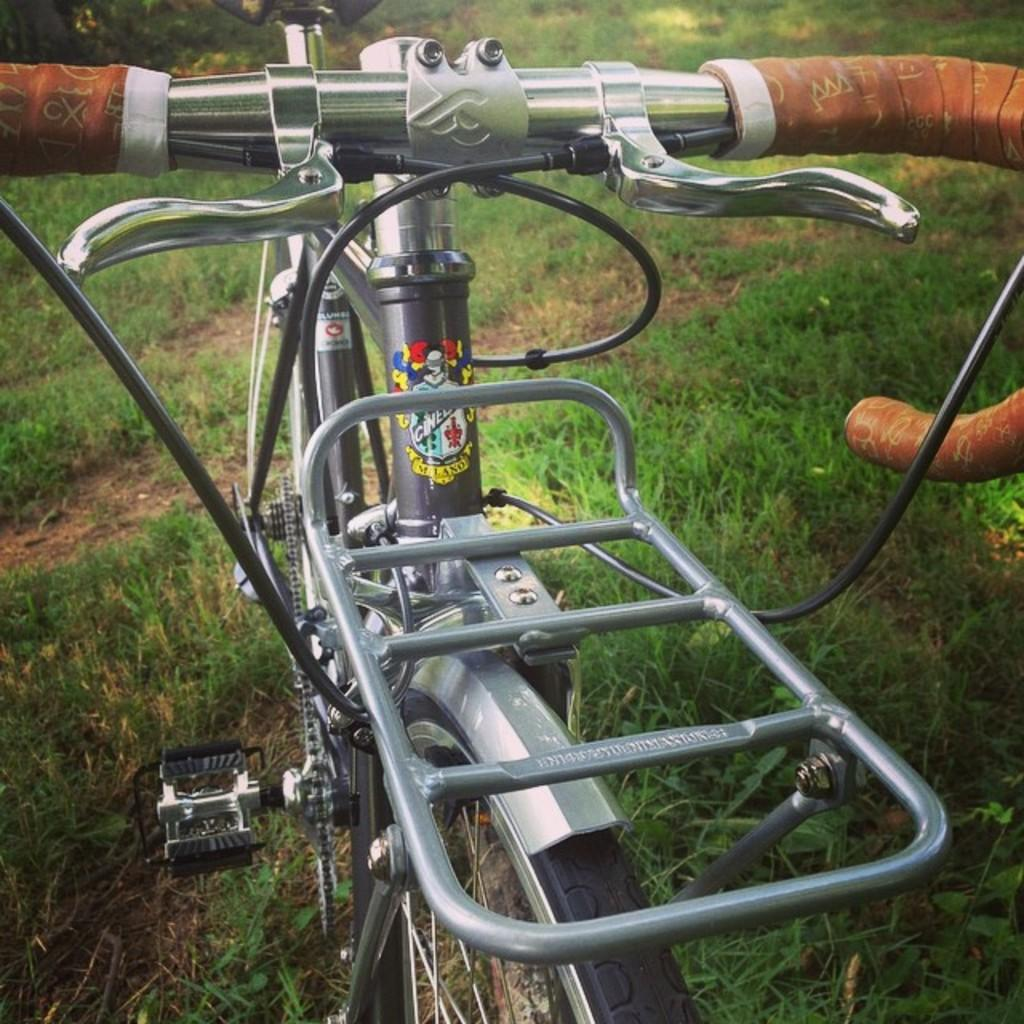What is the main object in the foreground of the image? There is a cycle in the foreground of the image. What type of vegetation can be seen in the background of the image? There is grass visible in the background of the image. Reasoning: Let'g: Let's think step by step in order to produce the conversation. We start by identifying the main object in the foreground, which is the cycle. Then, we describe the background by mentioning the type of vegetation present, which is grass. We avoid yes/no questions and ensure that the language is simple and clear. Absurd Question/Answer: What type of chain can be seen connecting the cycle to a crime scene in the image? There is no chain or crime scene present in the image; it only features a cycle in the foreground and grass in the background. 